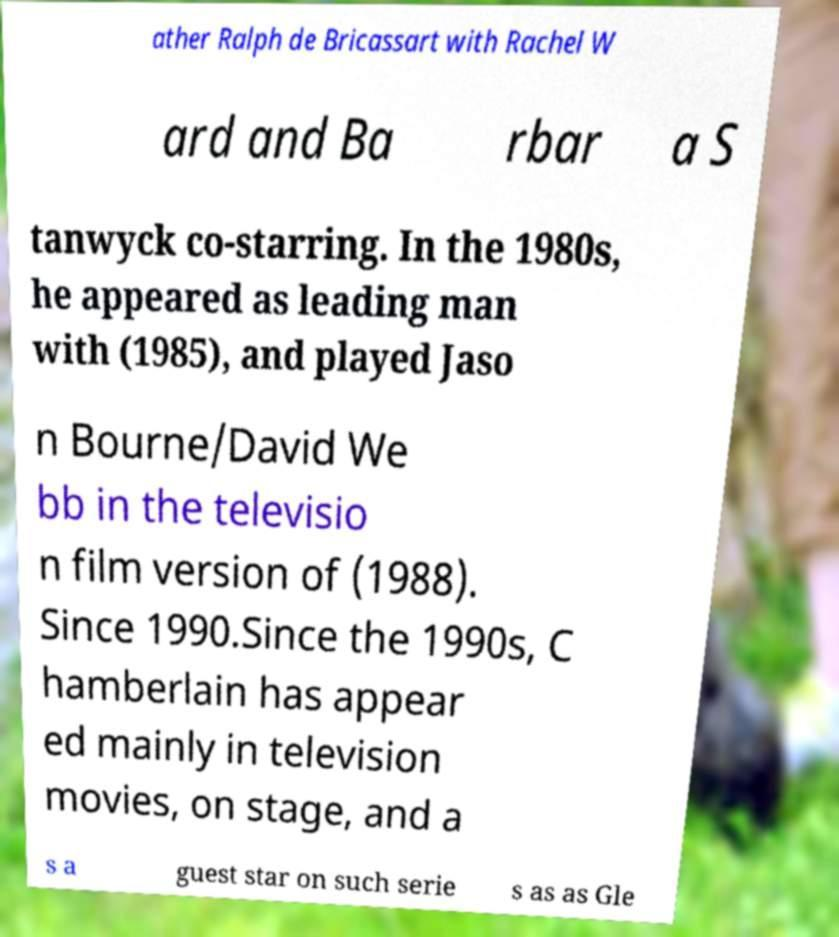I need the written content from this picture converted into text. Can you do that? ather Ralph de Bricassart with Rachel W ard and Ba rbar a S tanwyck co-starring. In the 1980s, he appeared as leading man with (1985), and played Jaso n Bourne/David We bb in the televisio n film version of (1988). Since 1990.Since the 1990s, C hamberlain has appear ed mainly in television movies, on stage, and a s a guest star on such serie s as as Gle 